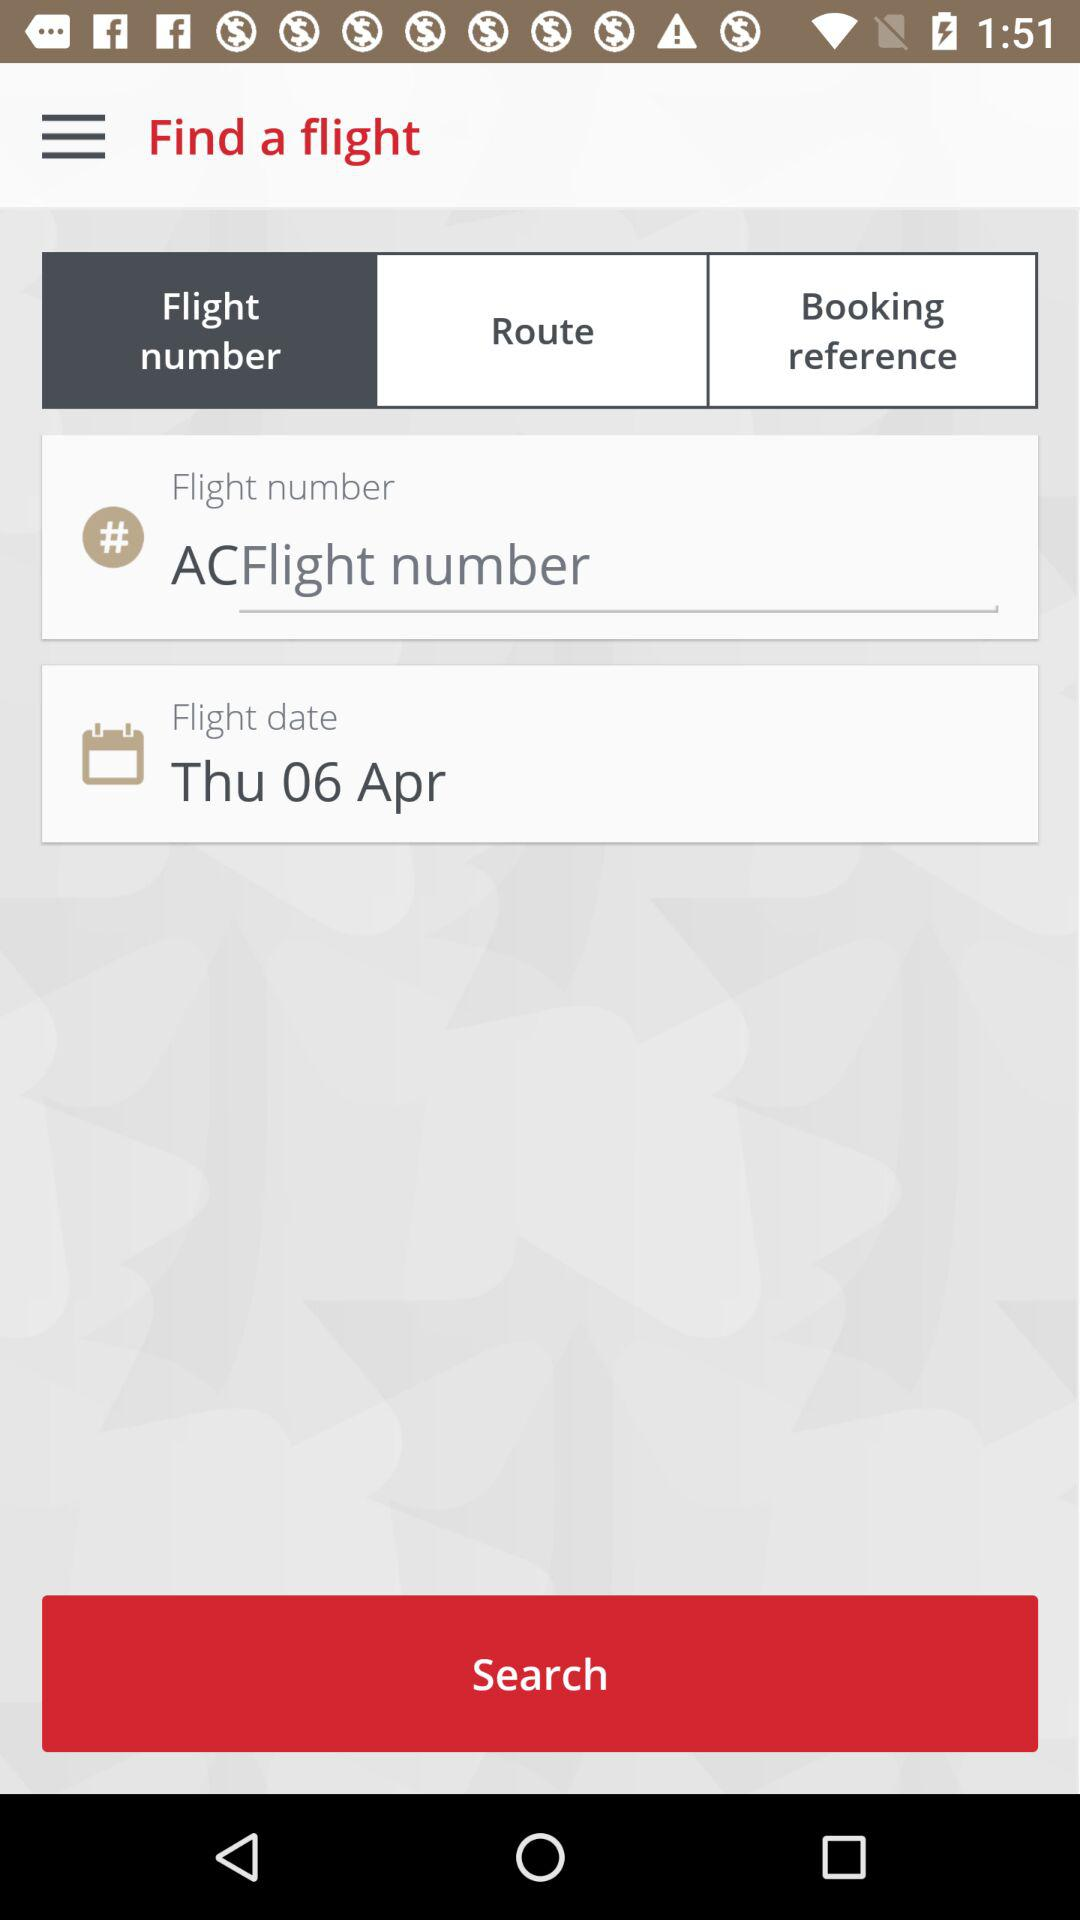How many input fields are required to search for a flight?
Answer the question using a single word or phrase. 2 